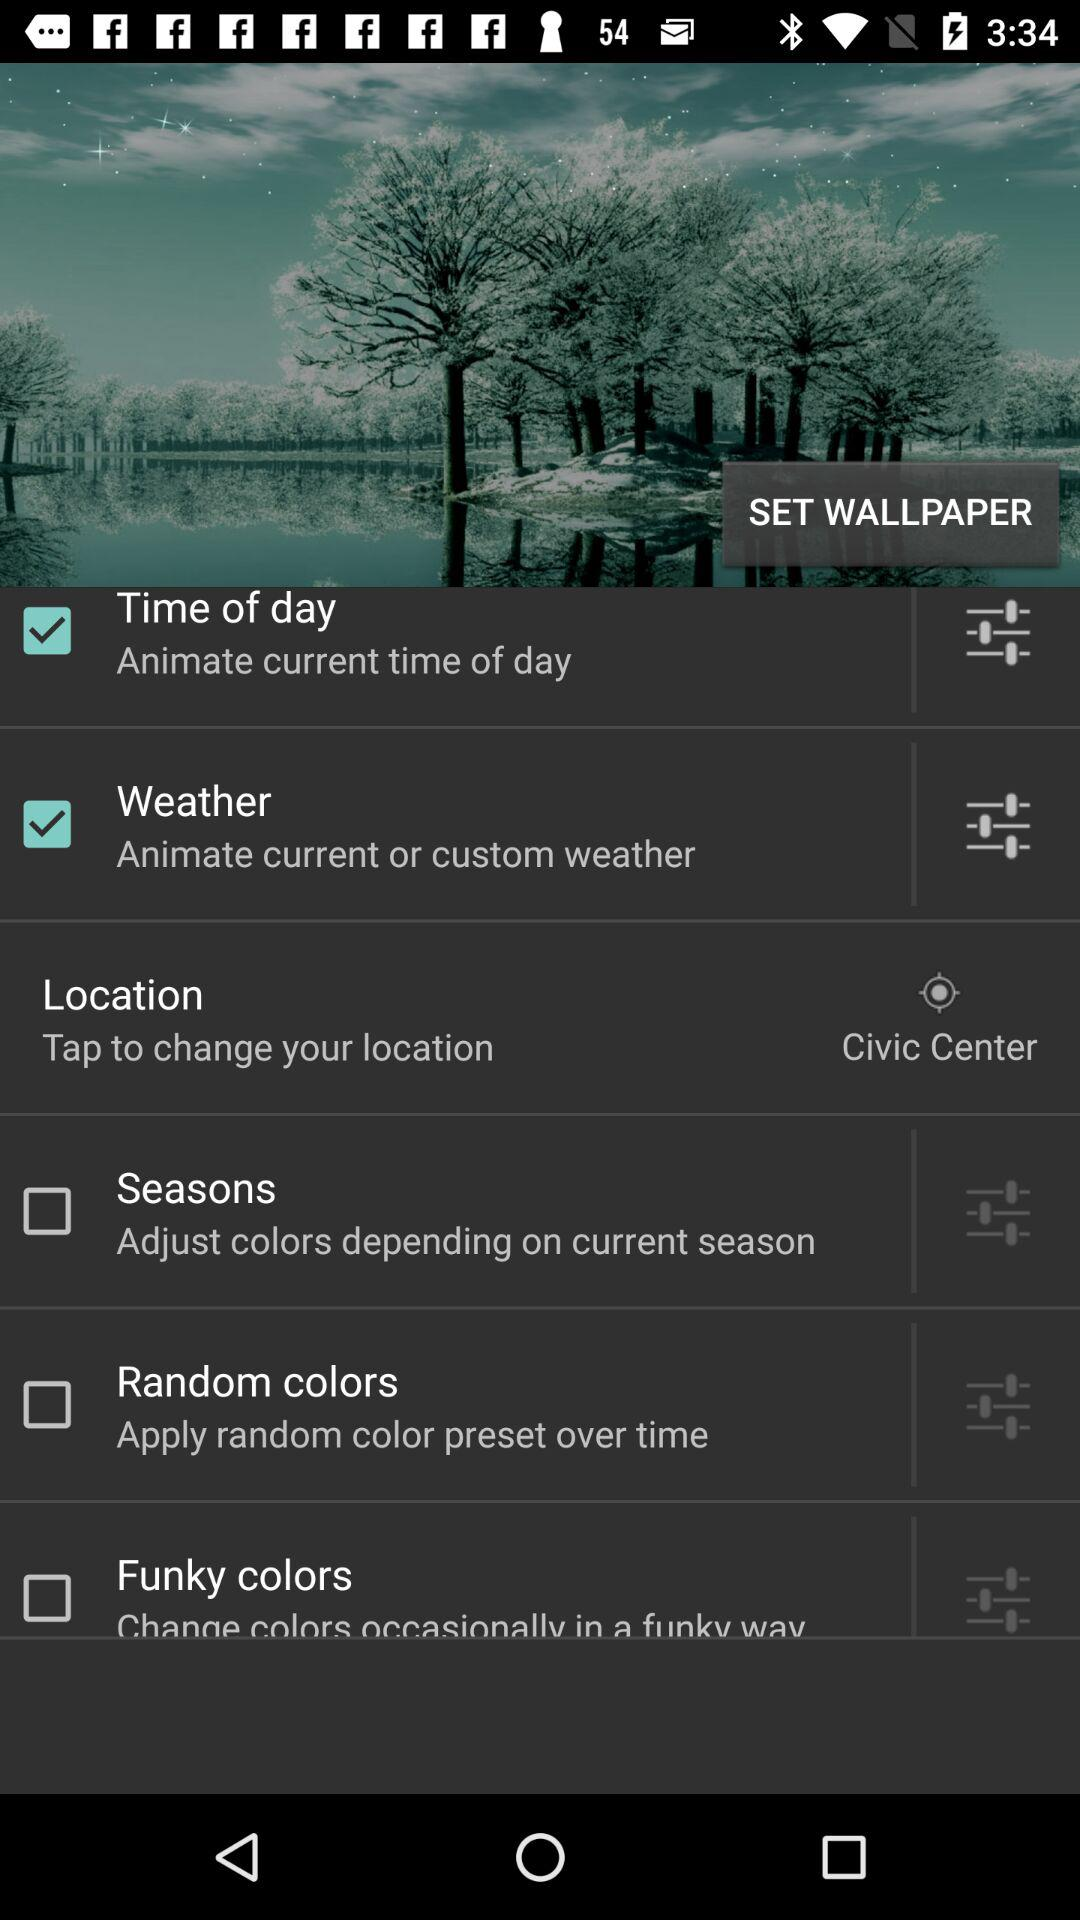What is the current status of the seasons? The current status of the seasons is off. 